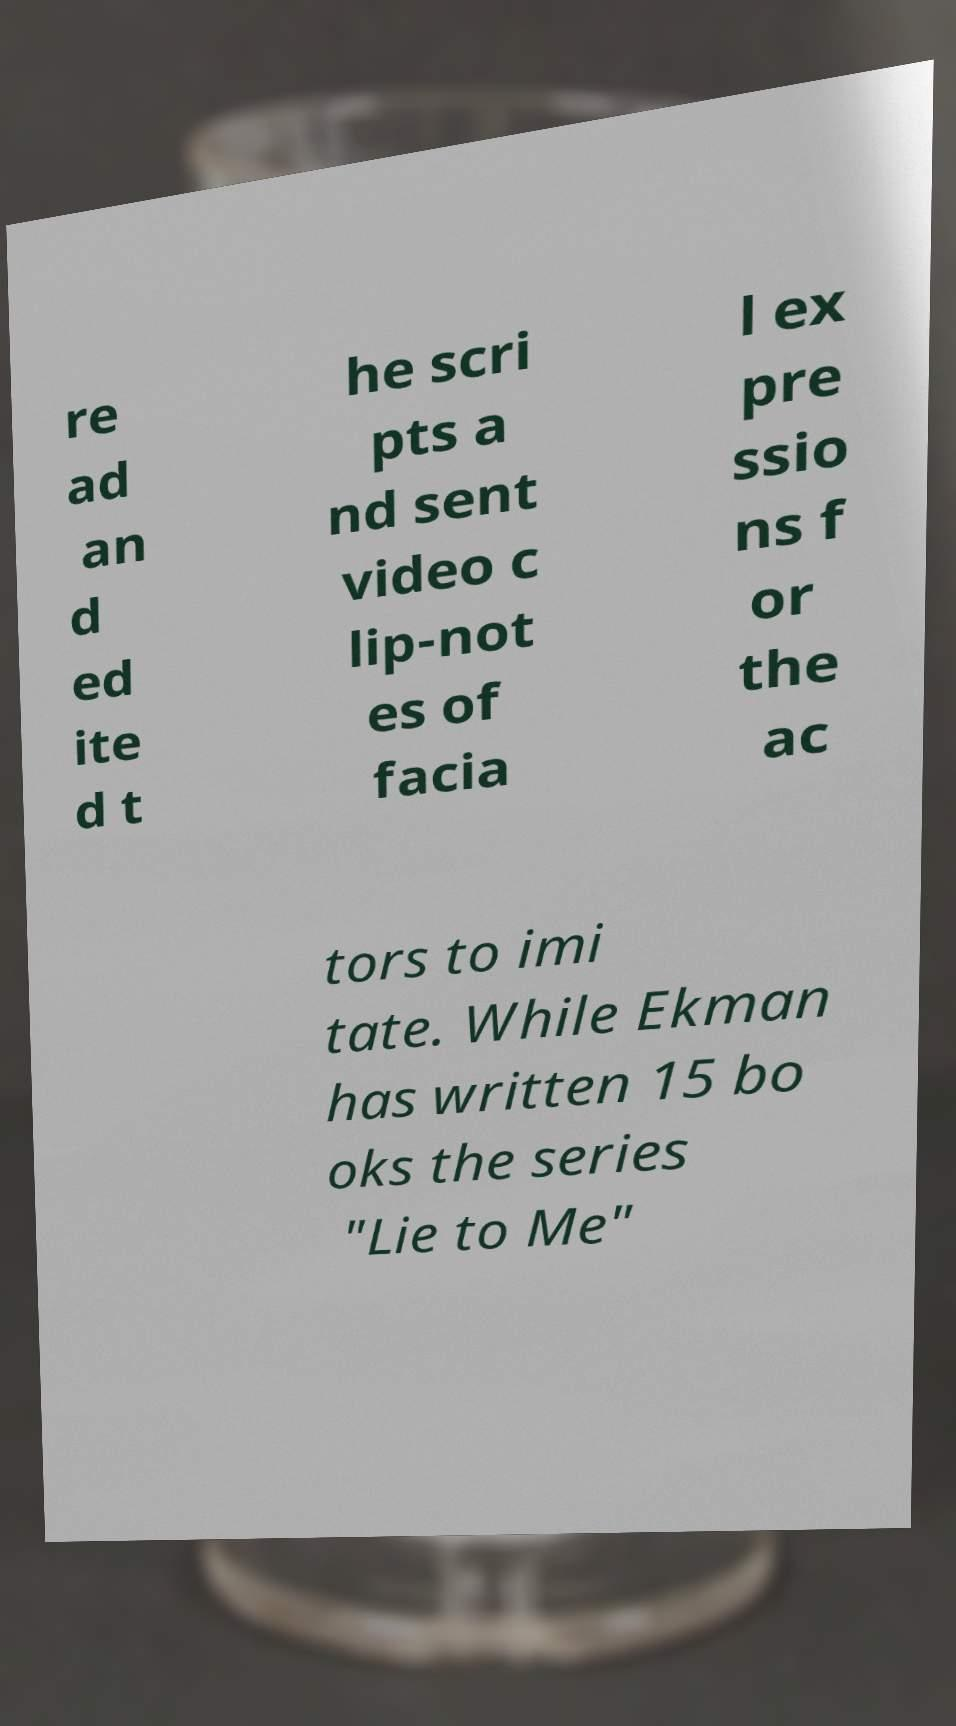For documentation purposes, I need the text within this image transcribed. Could you provide that? re ad an d ed ite d t he scri pts a nd sent video c lip-not es of facia l ex pre ssio ns f or the ac tors to imi tate. While Ekman has written 15 bo oks the series "Lie to Me" 